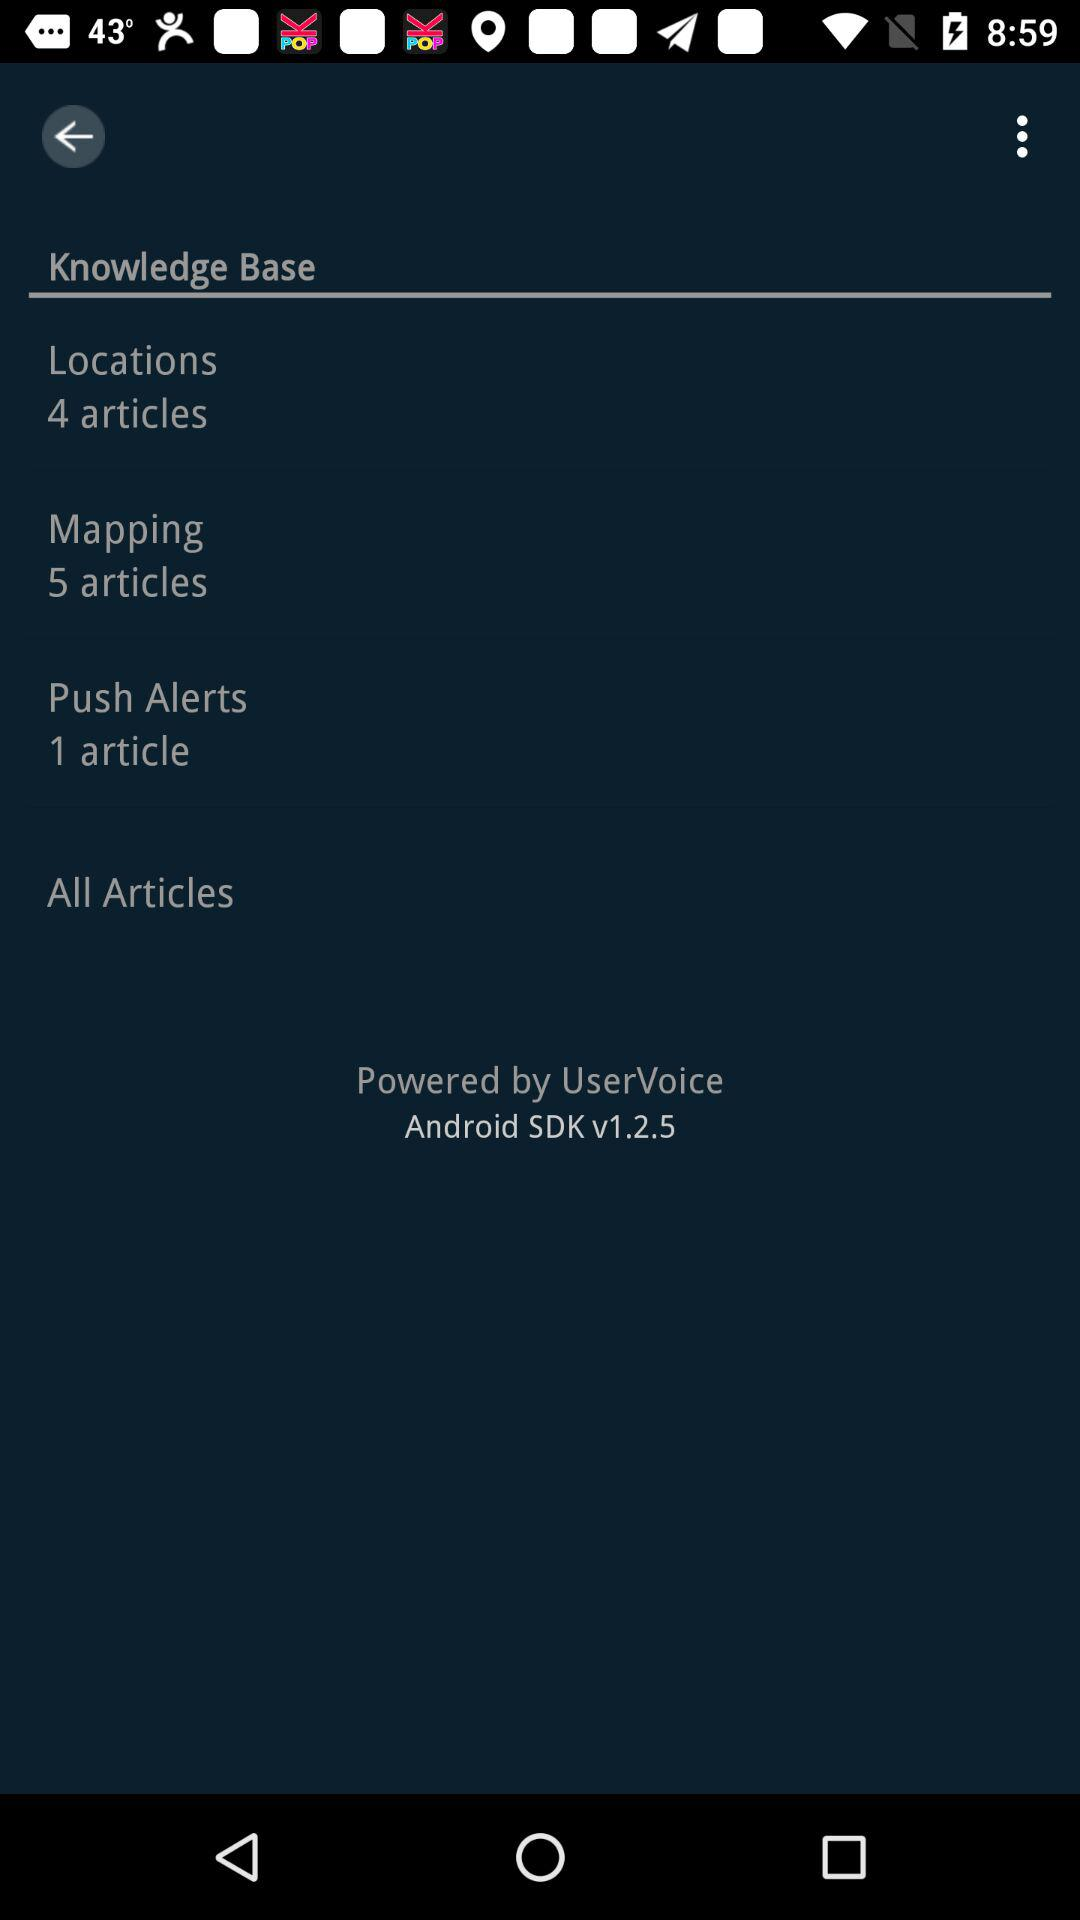How many more articles are there in the Mapping section than in the Locations section?
Answer the question using a single word or phrase. 1 